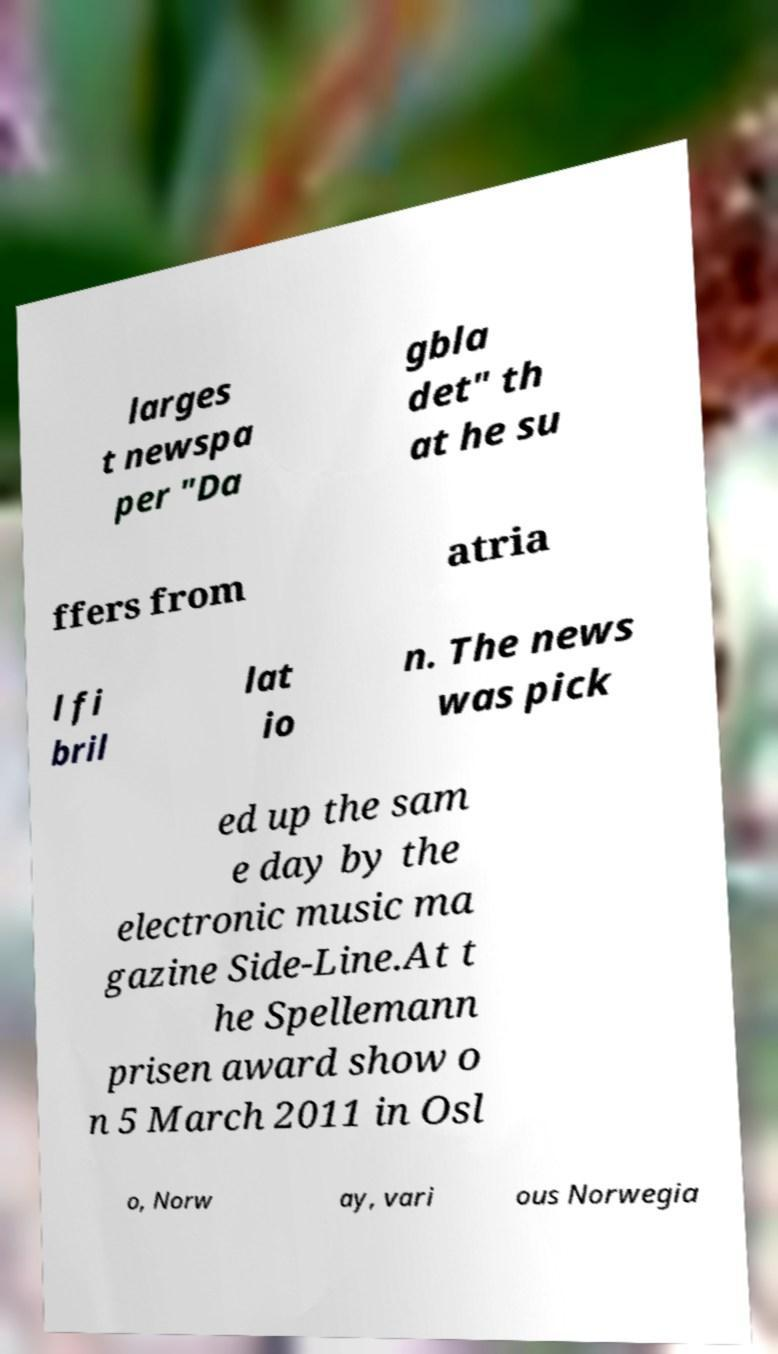Please identify and transcribe the text found in this image. larges t newspa per "Da gbla det" th at he su ffers from atria l fi bril lat io n. The news was pick ed up the sam e day by the electronic music ma gazine Side-Line.At t he Spellemann prisen award show o n 5 March 2011 in Osl o, Norw ay, vari ous Norwegia 